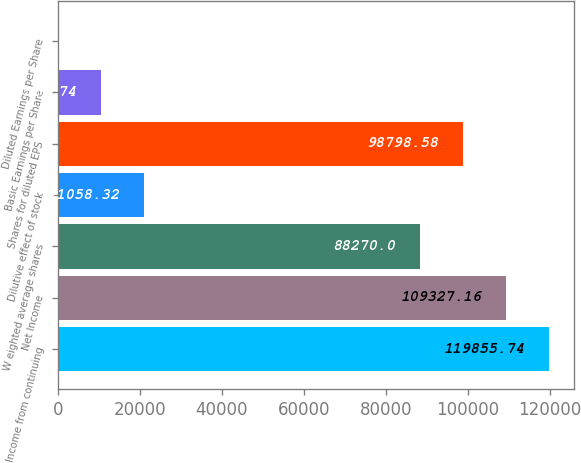<chart> <loc_0><loc_0><loc_500><loc_500><bar_chart><fcel>Income from continuing<fcel>Net Income<fcel>W eighted average shares<fcel>Dilutive effect of stock<fcel>Shares for diluted EPS<fcel>Basic Earnings per Share<fcel>Diluted Earnings per Share<nl><fcel>119856<fcel>109327<fcel>88270<fcel>21058.3<fcel>98798.6<fcel>10529.7<fcel>1.16<nl></chart> 